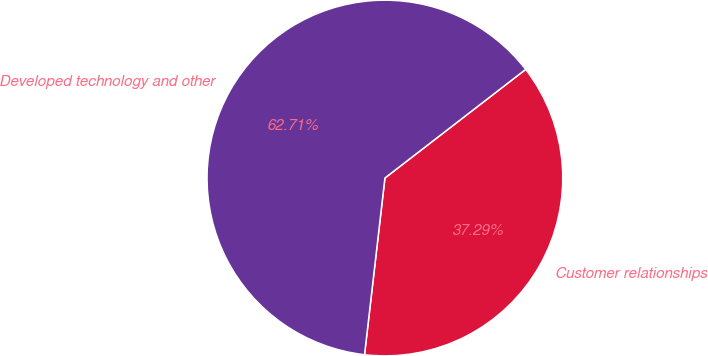Convert chart. <chart><loc_0><loc_0><loc_500><loc_500><pie_chart><fcel>Customer relationships<fcel>Developed technology and other<nl><fcel>37.29%<fcel>62.71%<nl></chart> 